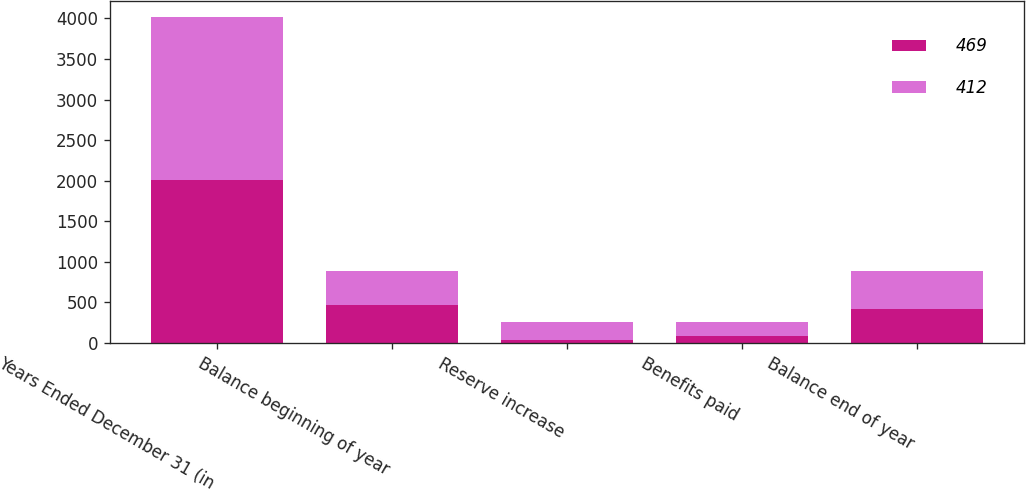<chart> <loc_0><loc_0><loc_500><loc_500><stacked_bar_chart><ecel><fcel>Years Ended December 31 (in<fcel>Balance beginning of year<fcel>Reserve increase<fcel>Benefits paid<fcel>Balance end of year<nl><fcel>469<fcel>2010<fcel>469<fcel>31<fcel>88<fcel>412<nl><fcel>412<fcel>2009<fcel>412<fcel>229<fcel>172<fcel>469<nl></chart> 